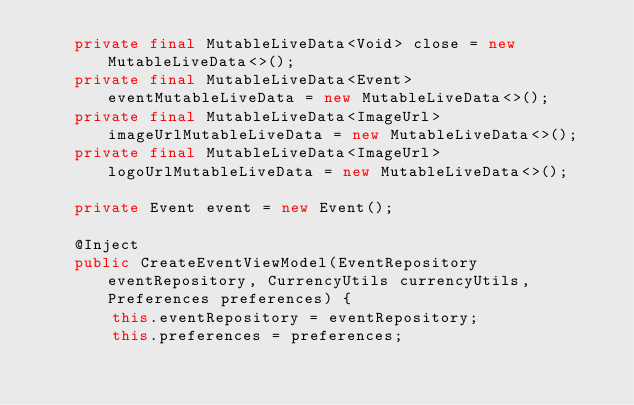Convert code to text. <code><loc_0><loc_0><loc_500><loc_500><_Java_>    private final MutableLiveData<Void> close = new MutableLiveData<>();
    private final MutableLiveData<Event> eventMutableLiveData = new MutableLiveData<>();
    private final MutableLiveData<ImageUrl> imageUrlMutableLiveData = new MutableLiveData<>();
    private final MutableLiveData<ImageUrl> logoUrlMutableLiveData = new MutableLiveData<>();

    private Event event = new Event();

    @Inject
    public CreateEventViewModel(EventRepository eventRepository, CurrencyUtils currencyUtils, Preferences preferences) {
        this.eventRepository = eventRepository;
        this.preferences = preferences;</code> 